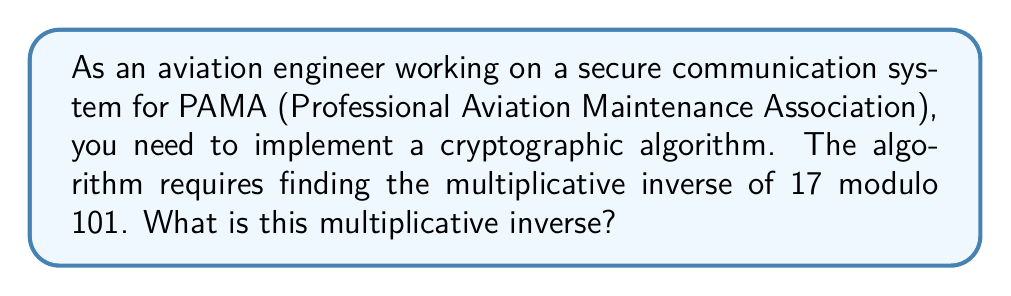Teach me how to tackle this problem. To find the multiplicative inverse of 17 modulo 101, we need to find a number $x$ such that:

$$(17 \cdot x) \equiv 1 \pmod{101}$$

We can use the Extended Euclidean Algorithm to solve this:

1) Start with the equation: $101 = 5 \cdot 17 + 16$
2) Rearrange: $16 = 101 - 5 \cdot 17$
3) Continue:
   $17 = 1 \cdot 16 + 1$
   $1 = 17 - 1 \cdot 16$

4) Substitute back:
   $1 = 17 - 1 \cdot (101 - 5 \cdot 17)$
   $1 = 6 \cdot 17 - 1 \cdot 101$

5) Therefore: $6 \cdot 17 \equiv 1 \pmod{101}$

6) This means 6 is the multiplicative inverse of 17 modulo 101.

7) Verify: $17 \cdot 6 = 102 \equiv 1 \pmod{101}$
Answer: 6 